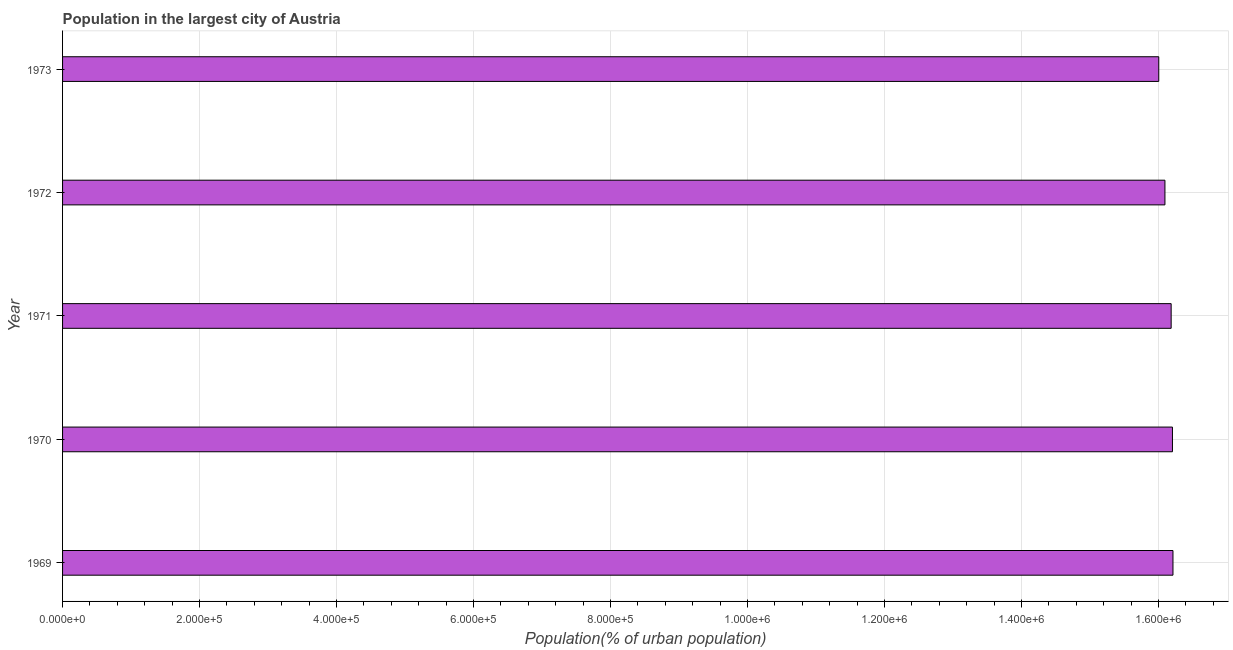Does the graph contain any zero values?
Provide a short and direct response. No. What is the title of the graph?
Give a very brief answer. Population in the largest city of Austria. What is the label or title of the X-axis?
Make the answer very short. Population(% of urban population). What is the label or title of the Y-axis?
Offer a terse response. Year. What is the population in largest city in 1970?
Provide a short and direct response. 1.62e+06. Across all years, what is the maximum population in largest city?
Ensure brevity in your answer.  1.62e+06. Across all years, what is the minimum population in largest city?
Give a very brief answer. 1.60e+06. In which year was the population in largest city maximum?
Provide a succinct answer. 1969. In which year was the population in largest city minimum?
Your answer should be compact. 1973. What is the sum of the population in largest city?
Give a very brief answer. 8.07e+06. What is the difference between the population in largest city in 1970 and 1973?
Offer a terse response. 2.00e+04. What is the average population in largest city per year?
Give a very brief answer. 1.61e+06. What is the median population in largest city?
Provide a short and direct response. 1.62e+06. Do a majority of the years between 1972 and 1971 (inclusive) have population in largest city greater than 720000 %?
Make the answer very short. No. Is the population in largest city in 1969 less than that in 1972?
Ensure brevity in your answer.  No. Is the difference between the population in largest city in 1969 and 1973 greater than the difference between any two years?
Your response must be concise. Yes. What is the difference between the highest and the second highest population in largest city?
Your answer should be compact. 756. Is the sum of the population in largest city in 1969 and 1972 greater than the maximum population in largest city across all years?
Offer a terse response. Yes. What is the difference between the highest and the lowest population in largest city?
Your response must be concise. 2.07e+04. In how many years, is the population in largest city greater than the average population in largest city taken over all years?
Provide a succinct answer. 3. How many bars are there?
Ensure brevity in your answer.  5. Are the values on the major ticks of X-axis written in scientific E-notation?
Your answer should be very brief. Yes. What is the Population(% of urban population) of 1969?
Ensure brevity in your answer.  1.62e+06. What is the Population(% of urban population) of 1970?
Your answer should be very brief. 1.62e+06. What is the Population(% of urban population) of 1971?
Provide a succinct answer. 1.62e+06. What is the Population(% of urban population) in 1972?
Offer a terse response. 1.61e+06. What is the Population(% of urban population) of 1973?
Keep it short and to the point. 1.60e+06. What is the difference between the Population(% of urban population) in 1969 and 1970?
Make the answer very short. 756. What is the difference between the Population(% of urban population) in 1969 and 1971?
Offer a very short reply. 2655. What is the difference between the Population(% of urban population) in 1969 and 1972?
Offer a terse response. 1.17e+04. What is the difference between the Population(% of urban population) in 1969 and 1973?
Make the answer very short. 2.07e+04. What is the difference between the Population(% of urban population) in 1970 and 1971?
Make the answer very short. 1899. What is the difference between the Population(% of urban population) in 1970 and 1972?
Make the answer very short. 1.10e+04. What is the difference between the Population(% of urban population) in 1970 and 1973?
Provide a short and direct response. 2.00e+04. What is the difference between the Population(% of urban population) in 1971 and 1972?
Give a very brief answer. 9085. What is the difference between the Population(% of urban population) in 1971 and 1973?
Ensure brevity in your answer.  1.81e+04. What is the difference between the Population(% of urban population) in 1972 and 1973?
Offer a very short reply. 9009. What is the ratio of the Population(% of urban population) in 1969 to that in 1970?
Offer a very short reply. 1. What is the ratio of the Population(% of urban population) in 1969 to that in 1971?
Your answer should be very brief. 1. What is the ratio of the Population(% of urban population) in 1969 to that in 1972?
Provide a succinct answer. 1.01. What is the ratio of the Population(% of urban population) in 1969 to that in 1973?
Your answer should be compact. 1.01. What is the ratio of the Population(% of urban population) in 1970 to that in 1972?
Keep it short and to the point. 1.01. What is the ratio of the Population(% of urban population) in 1970 to that in 1973?
Provide a short and direct response. 1.01. What is the ratio of the Population(% of urban population) in 1971 to that in 1972?
Your answer should be very brief. 1.01. What is the ratio of the Population(% of urban population) in 1972 to that in 1973?
Offer a very short reply. 1.01. 